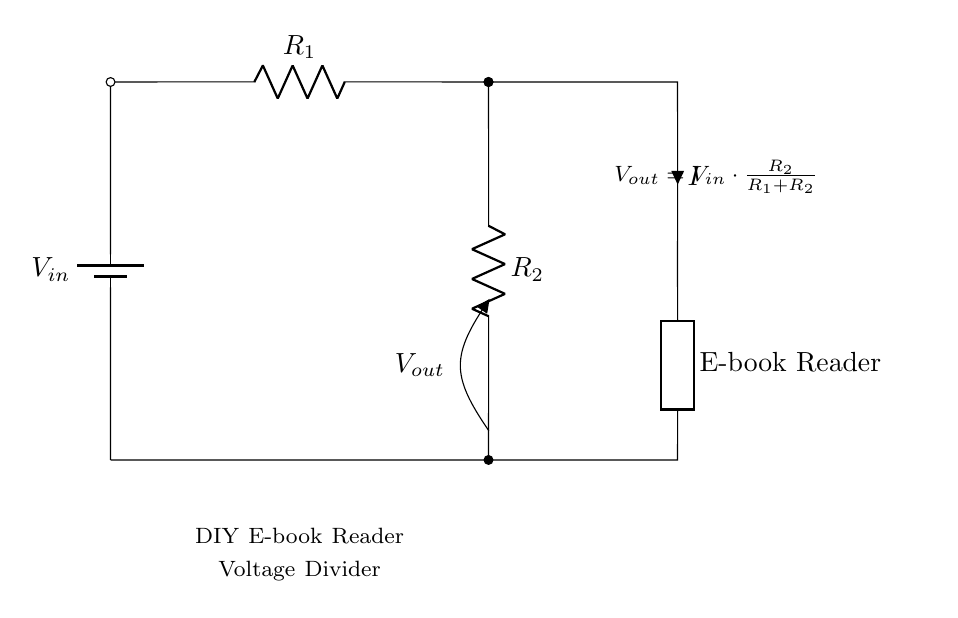What is the input voltage in the circuit? The input voltage, denoted as V in the diagram, represents the total voltage supplied by the battery. It is typically a specified value, though the specific value is not given in this circuit diagram itself.
Answer: V in What are the two resistors named in the circuit? The resistors in the circuit are labeled as R1 and R2, which are essential components of the voltage divider. They determine the distribution of voltage in the circuit based on their values.
Answer: R1 and R2 What does Vout represent in this diagram? Vout represents the output voltage across resistor R2 in the voltage divider circuit. This is the voltage that would be used to power the DIY E-book reader.
Answer: Output voltage What is the equation for Vout given in the circuit? The equation provided in the circuit states that Vout is equal to Vin multiplied by the fraction of R2 over the sum of R1 and R2. This equation is used to calculate the output voltage specifically.
Answer: Vout = Vin * (R2 / (R1 + R2)) Which component does Vout supply power to? Vout supplies power to the generic component labeled as E-book Reader in the circuit, indicating that this voltage is essential for its operation.
Answer: E-book Reader What will happen if R1 is much larger than R2? If R1 is significantly larger than R2, most of the input voltage will drop across R1, resulting in a very low output voltage Vout across R2, which may not be sufficient to power the E-book reader.
Answer: Low output voltage How does the total resistance affect the voltage output? The total resistance, which is the sum of R1 and R2, directly affects the output voltage through the voltage divider formula. A higher total resistance results in lower output voltage for a given input voltage.
Answer: Lower output voltage 